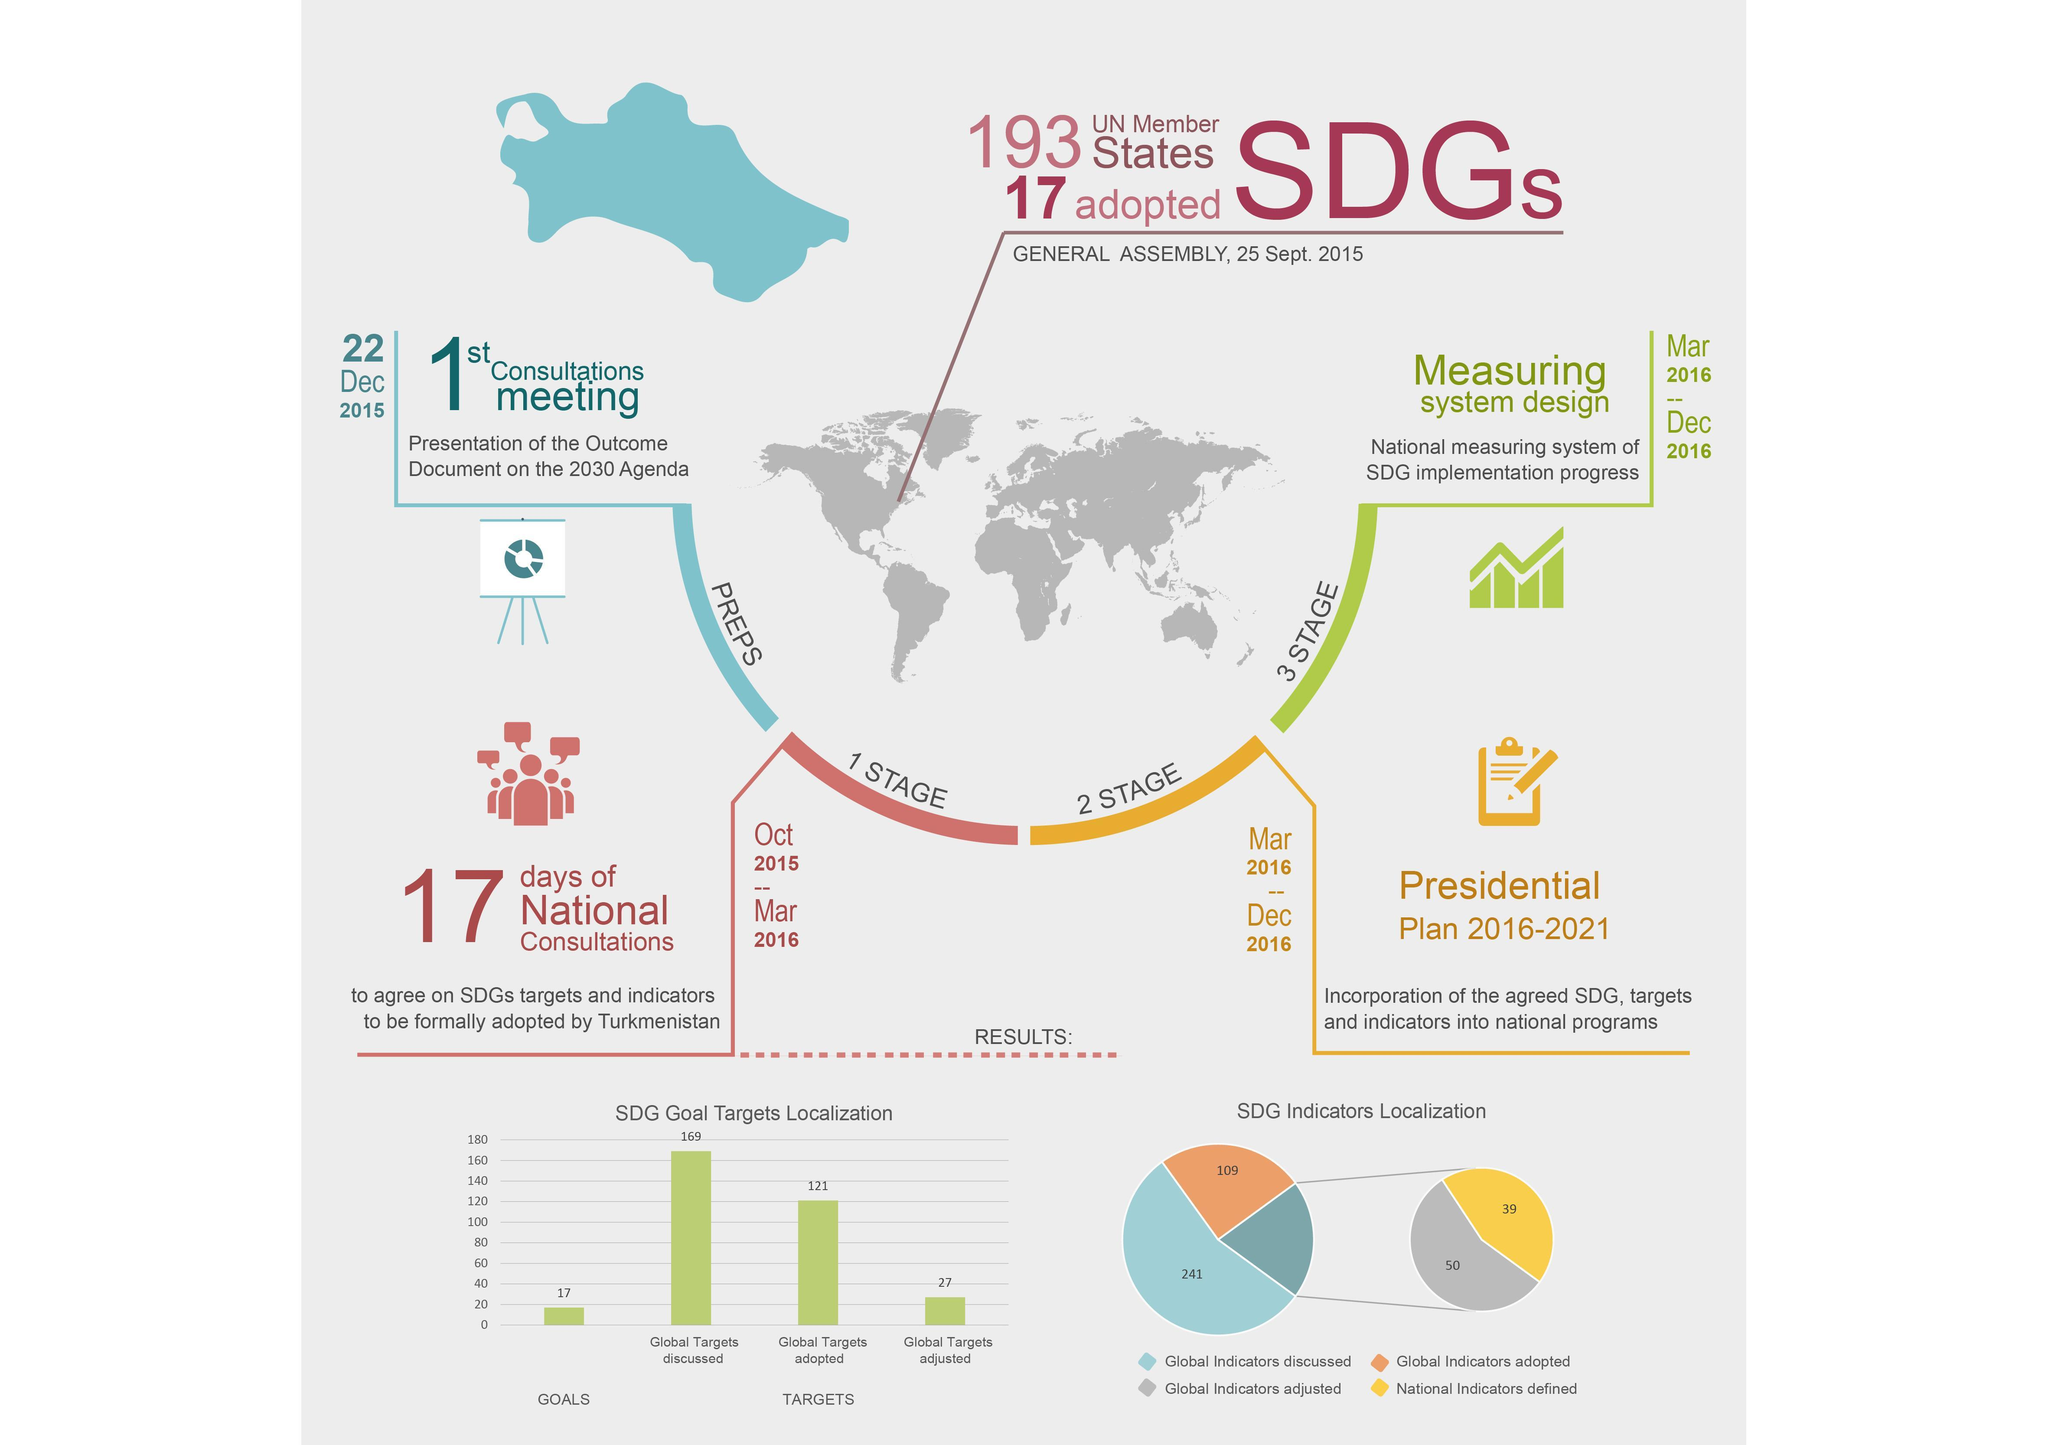Calculate the difference between the global targets discussed and targets adopted ?
Answer the question with a short phrase. 48 Which color depicts the preparation stage pink, orange, blue or green? blue 